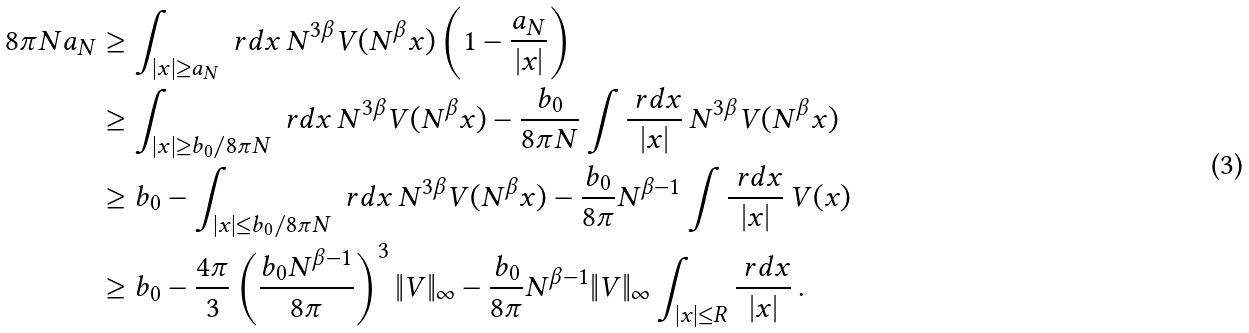<formula> <loc_0><loc_0><loc_500><loc_500>8 \pi N a _ { N } & \geq \int _ { | x | \geq a _ { N } } \ r d x \, N ^ { 3 \beta } V ( N ^ { \beta } x ) \left ( 1 - \frac { a _ { N } } { | x | } \right ) \\ & \geq \int _ { | x | \geq b _ { 0 } / 8 \pi N } \ r d x \, N ^ { 3 \beta } V ( N ^ { \beta } x ) - \frac { b _ { 0 } } { 8 \pi N } \int \frac { \ r d x } { | x | } \, N ^ { 3 \beta } V ( N ^ { \beta } x ) \\ & \geq b _ { 0 } - \int _ { | x | \leq b _ { 0 } / 8 \pi N } \ r d x \, N ^ { 3 \beta } V ( N ^ { \beta } x ) - \frac { b _ { 0 } } { 8 \pi } N ^ { \beta - 1 } \int \frac { \ r d x } { | x | } \, V ( x ) \\ & \geq b _ { 0 } - \frac { 4 \pi } { 3 } \left ( \frac { b _ { 0 } N ^ { \beta - 1 } } { 8 \pi } \right ) ^ { 3 } \| V \| _ { \infty } - \frac { b _ { 0 } } { 8 \pi } N ^ { \beta - 1 } \| V \| _ { \infty } \int _ { | x | \leq R } \frac { \ r d x } { | x | } \, .</formula> 